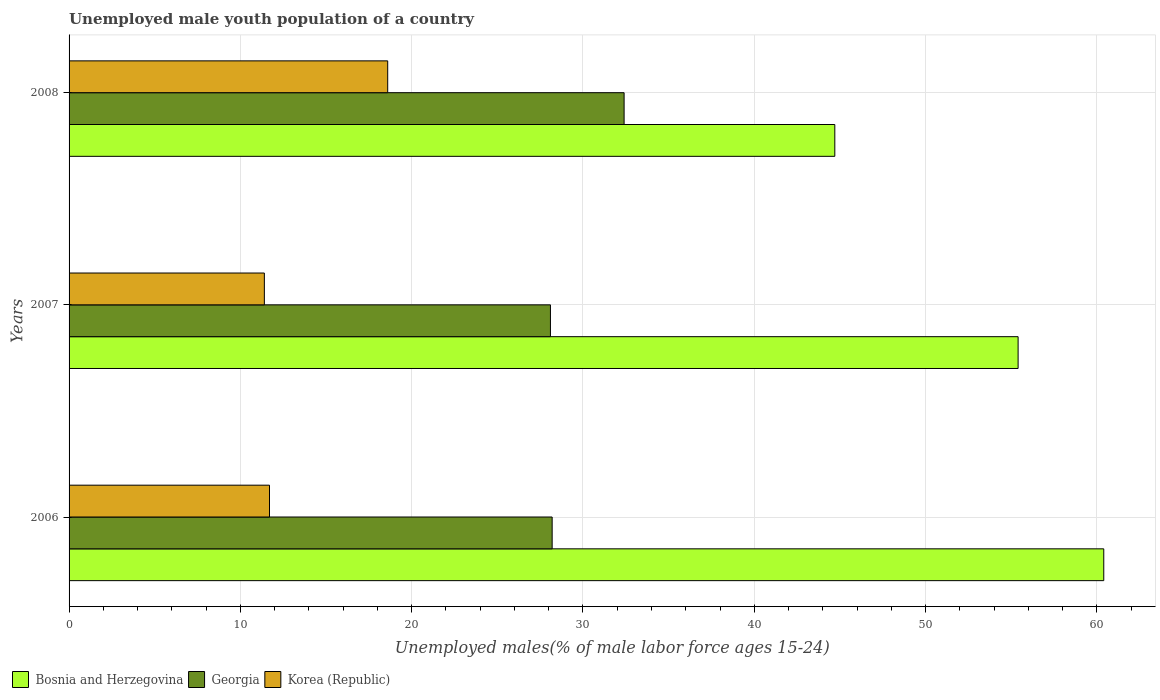Are the number of bars per tick equal to the number of legend labels?
Provide a short and direct response. Yes. Are the number of bars on each tick of the Y-axis equal?
Give a very brief answer. Yes. How many bars are there on the 2nd tick from the bottom?
Provide a short and direct response. 3. What is the percentage of unemployed male youth population in Georgia in 2007?
Make the answer very short. 28.1. Across all years, what is the maximum percentage of unemployed male youth population in Bosnia and Herzegovina?
Your answer should be very brief. 60.4. Across all years, what is the minimum percentage of unemployed male youth population in Bosnia and Herzegovina?
Your answer should be compact. 44.7. In which year was the percentage of unemployed male youth population in Korea (Republic) minimum?
Make the answer very short. 2007. What is the total percentage of unemployed male youth population in Bosnia and Herzegovina in the graph?
Your answer should be compact. 160.5. What is the difference between the percentage of unemployed male youth population in Korea (Republic) in 2007 and that in 2008?
Make the answer very short. -7.2. What is the difference between the percentage of unemployed male youth population in Georgia in 2006 and the percentage of unemployed male youth population in Bosnia and Herzegovina in 2008?
Your answer should be very brief. -16.5. What is the average percentage of unemployed male youth population in Bosnia and Herzegovina per year?
Provide a succinct answer. 53.5. In the year 2006, what is the difference between the percentage of unemployed male youth population in Bosnia and Herzegovina and percentage of unemployed male youth population in Korea (Republic)?
Keep it short and to the point. 48.7. What is the ratio of the percentage of unemployed male youth population in Korea (Republic) in 2006 to that in 2008?
Your answer should be very brief. 0.63. Is the percentage of unemployed male youth population in Georgia in 2007 less than that in 2008?
Your answer should be very brief. Yes. What is the difference between the highest and the second highest percentage of unemployed male youth population in Korea (Republic)?
Keep it short and to the point. 6.9. What is the difference between the highest and the lowest percentage of unemployed male youth population in Bosnia and Herzegovina?
Your response must be concise. 15.7. In how many years, is the percentage of unemployed male youth population in Korea (Republic) greater than the average percentage of unemployed male youth population in Korea (Republic) taken over all years?
Your response must be concise. 1. Is the sum of the percentage of unemployed male youth population in Bosnia and Herzegovina in 2006 and 2007 greater than the maximum percentage of unemployed male youth population in Georgia across all years?
Make the answer very short. Yes. What does the 1st bar from the top in 2006 represents?
Your response must be concise. Korea (Republic). What does the 1st bar from the bottom in 2006 represents?
Offer a terse response. Bosnia and Herzegovina. Is it the case that in every year, the sum of the percentage of unemployed male youth population in Korea (Republic) and percentage of unemployed male youth population in Bosnia and Herzegovina is greater than the percentage of unemployed male youth population in Georgia?
Provide a succinct answer. Yes. Are the values on the major ticks of X-axis written in scientific E-notation?
Offer a very short reply. No. Does the graph contain any zero values?
Give a very brief answer. No. Does the graph contain grids?
Your answer should be very brief. Yes. How many legend labels are there?
Your response must be concise. 3. How are the legend labels stacked?
Give a very brief answer. Horizontal. What is the title of the graph?
Ensure brevity in your answer.  Unemployed male youth population of a country. Does "Curacao" appear as one of the legend labels in the graph?
Make the answer very short. No. What is the label or title of the X-axis?
Give a very brief answer. Unemployed males(% of male labor force ages 15-24). What is the label or title of the Y-axis?
Ensure brevity in your answer.  Years. What is the Unemployed males(% of male labor force ages 15-24) of Bosnia and Herzegovina in 2006?
Ensure brevity in your answer.  60.4. What is the Unemployed males(% of male labor force ages 15-24) of Georgia in 2006?
Your answer should be very brief. 28.2. What is the Unemployed males(% of male labor force ages 15-24) in Korea (Republic) in 2006?
Your answer should be very brief. 11.7. What is the Unemployed males(% of male labor force ages 15-24) in Bosnia and Herzegovina in 2007?
Provide a short and direct response. 55.4. What is the Unemployed males(% of male labor force ages 15-24) of Georgia in 2007?
Offer a terse response. 28.1. What is the Unemployed males(% of male labor force ages 15-24) of Korea (Republic) in 2007?
Give a very brief answer. 11.4. What is the Unemployed males(% of male labor force ages 15-24) in Bosnia and Herzegovina in 2008?
Your answer should be compact. 44.7. What is the Unemployed males(% of male labor force ages 15-24) of Georgia in 2008?
Keep it short and to the point. 32.4. What is the Unemployed males(% of male labor force ages 15-24) of Korea (Republic) in 2008?
Provide a short and direct response. 18.6. Across all years, what is the maximum Unemployed males(% of male labor force ages 15-24) in Bosnia and Herzegovina?
Make the answer very short. 60.4. Across all years, what is the maximum Unemployed males(% of male labor force ages 15-24) of Georgia?
Ensure brevity in your answer.  32.4. Across all years, what is the maximum Unemployed males(% of male labor force ages 15-24) in Korea (Republic)?
Offer a terse response. 18.6. Across all years, what is the minimum Unemployed males(% of male labor force ages 15-24) in Bosnia and Herzegovina?
Make the answer very short. 44.7. Across all years, what is the minimum Unemployed males(% of male labor force ages 15-24) in Georgia?
Offer a terse response. 28.1. Across all years, what is the minimum Unemployed males(% of male labor force ages 15-24) in Korea (Republic)?
Offer a very short reply. 11.4. What is the total Unemployed males(% of male labor force ages 15-24) of Bosnia and Herzegovina in the graph?
Your response must be concise. 160.5. What is the total Unemployed males(% of male labor force ages 15-24) in Georgia in the graph?
Your response must be concise. 88.7. What is the total Unemployed males(% of male labor force ages 15-24) in Korea (Republic) in the graph?
Ensure brevity in your answer.  41.7. What is the difference between the Unemployed males(% of male labor force ages 15-24) of Bosnia and Herzegovina in 2006 and that in 2007?
Make the answer very short. 5. What is the difference between the Unemployed males(% of male labor force ages 15-24) in Korea (Republic) in 2006 and that in 2007?
Provide a short and direct response. 0.3. What is the difference between the Unemployed males(% of male labor force ages 15-24) in Bosnia and Herzegovina in 2006 and that in 2008?
Provide a succinct answer. 15.7. What is the difference between the Unemployed males(% of male labor force ages 15-24) of Georgia in 2006 and that in 2008?
Keep it short and to the point. -4.2. What is the difference between the Unemployed males(% of male labor force ages 15-24) of Korea (Republic) in 2007 and that in 2008?
Your answer should be very brief. -7.2. What is the difference between the Unemployed males(% of male labor force ages 15-24) of Bosnia and Herzegovina in 2006 and the Unemployed males(% of male labor force ages 15-24) of Georgia in 2007?
Give a very brief answer. 32.3. What is the difference between the Unemployed males(% of male labor force ages 15-24) of Bosnia and Herzegovina in 2006 and the Unemployed males(% of male labor force ages 15-24) of Korea (Republic) in 2007?
Your answer should be very brief. 49. What is the difference between the Unemployed males(% of male labor force ages 15-24) of Georgia in 2006 and the Unemployed males(% of male labor force ages 15-24) of Korea (Republic) in 2007?
Your answer should be compact. 16.8. What is the difference between the Unemployed males(% of male labor force ages 15-24) in Bosnia and Herzegovina in 2006 and the Unemployed males(% of male labor force ages 15-24) in Korea (Republic) in 2008?
Ensure brevity in your answer.  41.8. What is the difference between the Unemployed males(% of male labor force ages 15-24) in Bosnia and Herzegovina in 2007 and the Unemployed males(% of male labor force ages 15-24) in Georgia in 2008?
Your answer should be very brief. 23. What is the difference between the Unemployed males(% of male labor force ages 15-24) of Bosnia and Herzegovina in 2007 and the Unemployed males(% of male labor force ages 15-24) of Korea (Republic) in 2008?
Make the answer very short. 36.8. What is the average Unemployed males(% of male labor force ages 15-24) in Bosnia and Herzegovina per year?
Offer a terse response. 53.5. What is the average Unemployed males(% of male labor force ages 15-24) in Georgia per year?
Your answer should be very brief. 29.57. What is the average Unemployed males(% of male labor force ages 15-24) of Korea (Republic) per year?
Offer a terse response. 13.9. In the year 2006, what is the difference between the Unemployed males(% of male labor force ages 15-24) of Bosnia and Herzegovina and Unemployed males(% of male labor force ages 15-24) of Georgia?
Provide a succinct answer. 32.2. In the year 2006, what is the difference between the Unemployed males(% of male labor force ages 15-24) in Bosnia and Herzegovina and Unemployed males(% of male labor force ages 15-24) in Korea (Republic)?
Offer a terse response. 48.7. In the year 2006, what is the difference between the Unemployed males(% of male labor force ages 15-24) of Georgia and Unemployed males(% of male labor force ages 15-24) of Korea (Republic)?
Your answer should be very brief. 16.5. In the year 2007, what is the difference between the Unemployed males(% of male labor force ages 15-24) of Bosnia and Herzegovina and Unemployed males(% of male labor force ages 15-24) of Georgia?
Keep it short and to the point. 27.3. In the year 2007, what is the difference between the Unemployed males(% of male labor force ages 15-24) of Georgia and Unemployed males(% of male labor force ages 15-24) of Korea (Republic)?
Ensure brevity in your answer.  16.7. In the year 2008, what is the difference between the Unemployed males(% of male labor force ages 15-24) in Bosnia and Herzegovina and Unemployed males(% of male labor force ages 15-24) in Korea (Republic)?
Your answer should be very brief. 26.1. What is the ratio of the Unemployed males(% of male labor force ages 15-24) of Bosnia and Herzegovina in 2006 to that in 2007?
Offer a very short reply. 1.09. What is the ratio of the Unemployed males(% of male labor force ages 15-24) in Korea (Republic) in 2006 to that in 2007?
Provide a short and direct response. 1.03. What is the ratio of the Unemployed males(% of male labor force ages 15-24) of Bosnia and Herzegovina in 2006 to that in 2008?
Provide a short and direct response. 1.35. What is the ratio of the Unemployed males(% of male labor force ages 15-24) of Georgia in 2006 to that in 2008?
Offer a very short reply. 0.87. What is the ratio of the Unemployed males(% of male labor force ages 15-24) of Korea (Republic) in 2006 to that in 2008?
Your answer should be very brief. 0.63. What is the ratio of the Unemployed males(% of male labor force ages 15-24) of Bosnia and Herzegovina in 2007 to that in 2008?
Your response must be concise. 1.24. What is the ratio of the Unemployed males(% of male labor force ages 15-24) in Georgia in 2007 to that in 2008?
Make the answer very short. 0.87. What is the ratio of the Unemployed males(% of male labor force ages 15-24) of Korea (Republic) in 2007 to that in 2008?
Your answer should be compact. 0.61. What is the difference between the highest and the second highest Unemployed males(% of male labor force ages 15-24) in Korea (Republic)?
Your answer should be very brief. 6.9. 